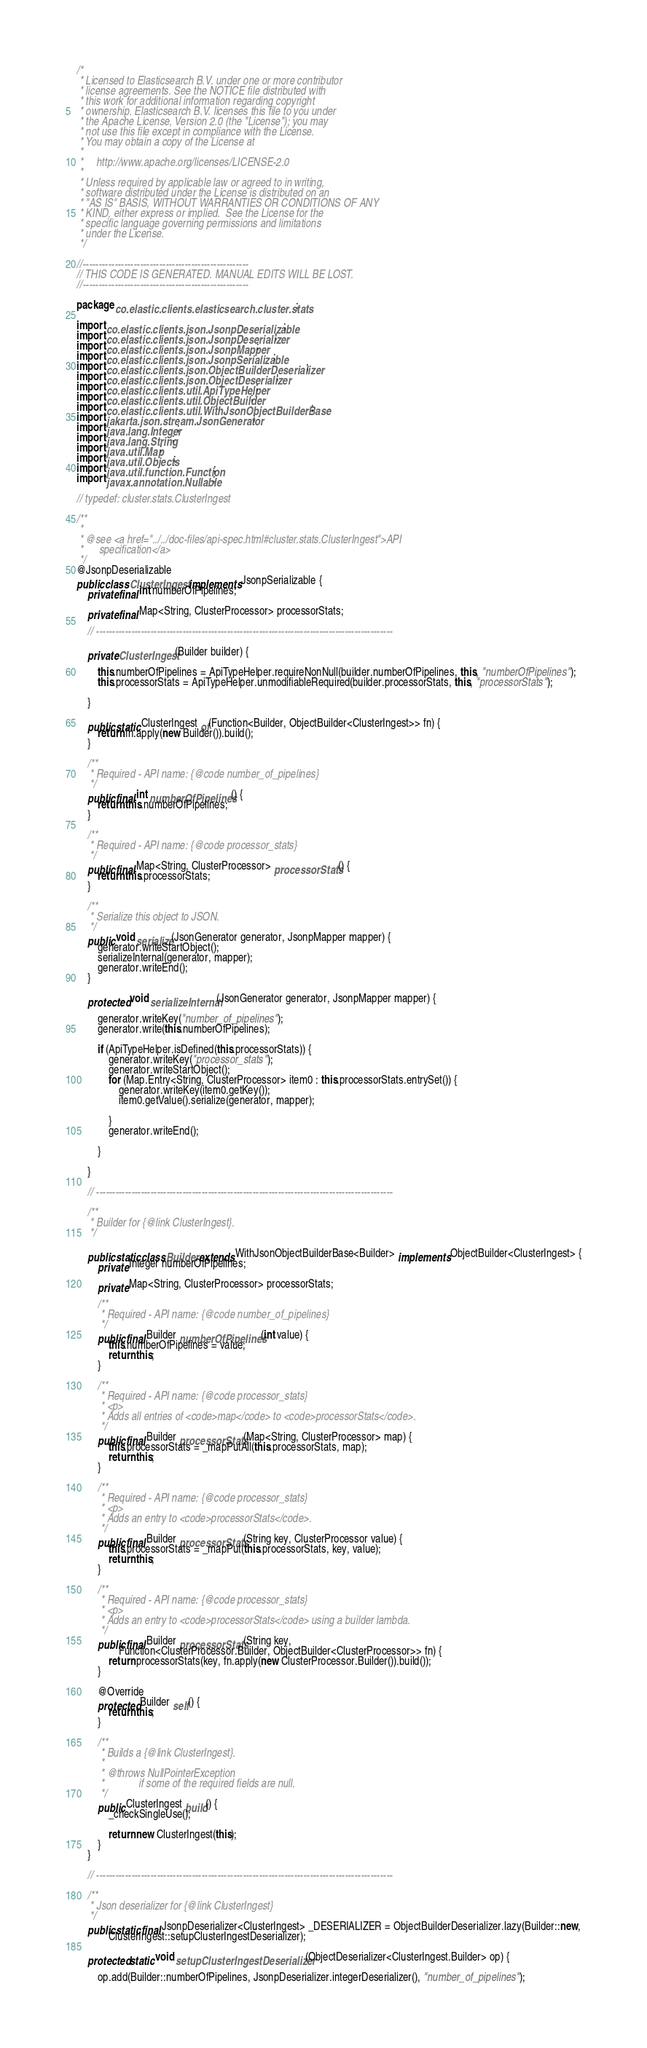<code> <loc_0><loc_0><loc_500><loc_500><_Java_>/*
 * Licensed to Elasticsearch B.V. under one or more contributor
 * license agreements. See the NOTICE file distributed with
 * this work for additional information regarding copyright
 * ownership. Elasticsearch B.V. licenses this file to you under
 * the Apache License, Version 2.0 (the "License"); you may
 * not use this file except in compliance with the License.
 * You may obtain a copy of the License at
 *
 *     http://www.apache.org/licenses/LICENSE-2.0
 *
 * Unless required by applicable law or agreed to in writing,
 * software distributed under the License is distributed on an
 * "AS IS" BASIS, WITHOUT WARRANTIES OR CONDITIONS OF ANY
 * KIND, either express or implied.  See the License for the
 * specific language governing permissions and limitations
 * under the License.
 */

//----------------------------------------------------
// THIS CODE IS GENERATED. MANUAL EDITS WILL BE LOST.
//----------------------------------------------------

package co.elastic.clients.elasticsearch.cluster.stats;

import co.elastic.clients.json.JsonpDeserializable;
import co.elastic.clients.json.JsonpDeserializer;
import co.elastic.clients.json.JsonpMapper;
import co.elastic.clients.json.JsonpSerializable;
import co.elastic.clients.json.ObjectBuilderDeserializer;
import co.elastic.clients.json.ObjectDeserializer;
import co.elastic.clients.util.ApiTypeHelper;
import co.elastic.clients.util.ObjectBuilder;
import co.elastic.clients.util.WithJsonObjectBuilderBase;
import jakarta.json.stream.JsonGenerator;
import java.lang.Integer;
import java.lang.String;
import java.util.Map;
import java.util.Objects;
import java.util.function.Function;
import javax.annotation.Nullable;

// typedef: cluster.stats.ClusterIngest

/**
 *
 * @see <a href="../../doc-files/api-spec.html#cluster.stats.ClusterIngest">API
 *      specification</a>
 */
@JsonpDeserializable
public class ClusterIngest implements JsonpSerializable {
	private final int numberOfPipelines;

	private final Map<String, ClusterProcessor> processorStats;

	// ---------------------------------------------------------------------------------------------

	private ClusterIngest(Builder builder) {

		this.numberOfPipelines = ApiTypeHelper.requireNonNull(builder.numberOfPipelines, this, "numberOfPipelines");
		this.processorStats = ApiTypeHelper.unmodifiableRequired(builder.processorStats, this, "processorStats");

	}

	public static ClusterIngest of(Function<Builder, ObjectBuilder<ClusterIngest>> fn) {
		return fn.apply(new Builder()).build();
	}

	/**
	 * Required - API name: {@code number_of_pipelines}
	 */
	public final int numberOfPipelines() {
		return this.numberOfPipelines;
	}

	/**
	 * Required - API name: {@code processor_stats}
	 */
	public final Map<String, ClusterProcessor> processorStats() {
		return this.processorStats;
	}

	/**
	 * Serialize this object to JSON.
	 */
	public void serialize(JsonGenerator generator, JsonpMapper mapper) {
		generator.writeStartObject();
		serializeInternal(generator, mapper);
		generator.writeEnd();
	}

	protected void serializeInternal(JsonGenerator generator, JsonpMapper mapper) {

		generator.writeKey("number_of_pipelines");
		generator.write(this.numberOfPipelines);

		if (ApiTypeHelper.isDefined(this.processorStats)) {
			generator.writeKey("processor_stats");
			generator.writeStartObject();
			for (Map.Entry<String, ClusterProcessor> item0 : this.processorStats.entrySet()) {
				generator.writeKey(item0.getKey());
				item0.getValue().serialize(generator, mapper);

			}
			generator.writeEnd();

		}

	}

	// ---------------------------------------------------------------------------------------------

	/**
	 * Builder for {@link ClusterIngest}.
	 */

	public static class Builder extends WithJsonObjectBuilderBase<Builder> implements ObjectBuilder<ClusterIngest> {
		private Integer numberOfPipelines;

		private Map<String, ClusterProcessor> processorStats;

		/**
		 * Required - API name: {@code number_of_pipelines}
		 */
		public final Builder numberOfPipelines(int value) {
			this.numberOfPipelines = value;
			return this;
		}

		/**
		 * Required - API name: {@code processor_stats}
		 * <p>
		 * Adds all entries of <code>map</code> to <code>processorStats</code>.
		 */
		public final Builder processorStats(Map<String, ClusterProcessor> map) {
			this.processorStats = _mapPutAll(this.processorStats, map);
			return this;
		}

		/**
		 * Required - API name: {@code processor_stats}
		 * <p>
		 * Adds an entry to <code>processorStats</code>.
		 */
		public final Builder processorStats(String key, ClusterProcessor value) {
			this.processorStats = _mapPut(this.processorStats, key, value);
			return this;
		}

		/**
		 * Required - API name: {@code processor_stats}
		 * <p>
		 * Adds an entry to <code>processorStats</code> using a builder lambda.
		 */
		public final Builder processorStats(String key,
				Function<ClusterProcessor.Builder, ObjectBuilder<ClusterProcessor>> fn) {
			return processorStats(key, fn.apply(new ClusterProcessor.Builder()).build());
		}

		@Override
		protected Builder self() {
			return this;
		}

		/**
		 * Builds a {@link ClusterIngest}.
		 *
		 * @throws NullPointerException
		 *             if some of the required fields are null.
		 */
		public ClusterIngest build() {
			_checkSingleUse();

			return new ClusterIngest(this);
		}
	}

	// ---------------------------------------------------------------------------------------------

	/**
	 * Json deserializer for {@link ClusterIngest}
	 */
	public static final JsonpDeserializer<ClusterIngest> _DESERIALIZER = ObjectBuilderDeserializer.lazy(Builder::new,
			ClusterIngest::setupClusterIngestDeserializer);

	protected static void setupClusterIngestDeserializer(ObjectDeserializer<ClusterIngest.Builder> op) {

		op.add(Builder::numberOfPipelines, JsonpDeserializer.integerDeserializer(), "number_of_pipelines");</code> 